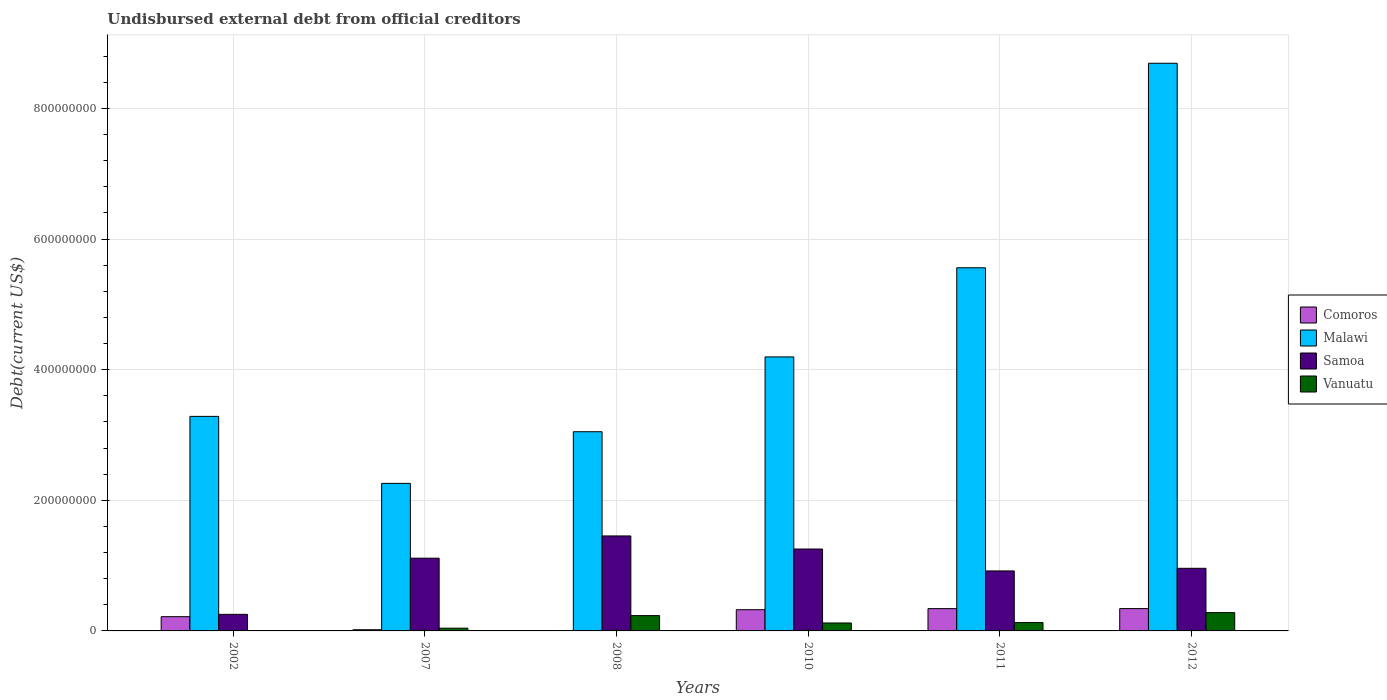How many groups of bars are there?
Your answer should be very brief. 6. Are the number of bars on each tick of the X-axis equal?
Offer a very short reply. Yes. What is the label of the 3rd group of bars from the left?
Your response must be concise. 2008. In how many cases, is the number of bars for a given year not equal to the number of legend labels?
Keep it short and to the point. 0. What is the total debt in Comoros in 2007?
Keep it short and to the point. 1.80e+06. Across all years, what is the maximum total debt in Malawi?
Keep it short and to the point. 8.69e+08. Across all years, what is the minimum total debt in Malawi?
Provide a short and direct response. 2.26e+08. In which year was the total debt in Vanuatu minimum?
Your answer should be very brief. 2002. What is the total total debt in Vanuatu in the graph?
Offer a terse response. 8.06e+07. What is the difference between the total debt in Samoa in 2008 and that in 2011?
Your answer should be very brief. 5.36e+07. What is the difference between the total debt in Malawi in 2011 and the total debt in Comoros in 2002?
Make the answer very short. 5.34e+08. What is the average total debt in Malawi per year?
Provide a succinct answer. 4.51e+08. In the year 2008, what is the difference between the total debt in Malawi and total debt in Comoros?
Give a very brief answer. 3.04e+08. What is the ratio of the total debt in Malawi in 2007 to that in 2012?
Give a very brief answer. 0.26. Is the difference between the total debt in Malawi in 2002 and 2012 greater than the difference between the total debt in Comoros in 2002 and 2012?
Make the answer very short. No. What is the difference between the highest and the second highest total debt in Vanuatu?
Your answer should be very brief. 4.56e+06. What is the difference between the highest and the lowest total debt in Comoros?
Offer a terse response. 3.37e+07. What does the 2nd bar from the left in 2007 represents?
Offer a terse response. Malawi. What does the 4th bar from the right in 2007 represents?
Keep it short and to the point. Comoros. Is it the case that in every year, the sum of the total debt in Comoros and total debt in Malawi is greater than the total debt in Samoa?
Provide a short and direct response. Yes. How many bars are there?
Give a very brief answer. 24. How many years are there in the graph?
Keep it short and to the point. 6. What is the difference between two consecutive major ticks on the Y-axis?
Provide a succinct answer. 2.00e+08. Are the values on the major ticks of Y-axis written in scientific E-notation?
Give a very brief answer. No. Does the graph contain any zero values?
Make the answer very short. No. Does the graph contain grids?
Offer a very short reply. Yes. How are the legend labels stacked?
Give a very brief answer. Vertical. What is the title of the graph?
Provide a succinct answer. Undisbursed external debt from official creditors. What is the label or title of the X-axis?
Your answer should be compact. Years. What is the label or title of the Y-axis?
Keep it short and to the point. Debt(current US$). What is the Debt(current US$) in Comoros in 2002?
Your answer should be very brief. 2.18e+07. What is the Debt(current US$) in Malawi in 2002?
Ensure brevity in your answer.  3.28e+08. What is the Debt(current US$) of Samoa in 2002?
Ensure brevity in your answer.  2.54e+07. What is the Debt(current US$) of Vanuatu in 2002?
Ensure brevity in your answer.  1.20e+04. What is the Debt(current US$) of Comoros in 2007?
Your response must be concise. 1.80e+06. What is the Debt(current US$) of Malawi in 2007?
Offer a terse response. 2.26e+08. What is the Debt(current US$) of Samoa in 2007?
Keep it short and to the point. 1.11e+08. What is the Debt(current US$) of Vanuatu in 2007?
Offer a terse response. 4.20e+06. What is the Debt(current US$) of Comoros in 2008?
Your answer should be compact. 4.97e+05. What is the Debt(current US$) of Malawi in 2008?
Your answer should be compact. 3.05e+08. What is the Debt(current US$) in Samoa in 2008?
Provide a short and direct response. 1.45e+08. What is the Debt(current US$) in Vanuatu in 2008?
Your response must be concise. 2.34e+07. What is the Debt(current US$) of Comoros in 2010?
Offer a terse response. 3.25e+07. What is the Debt(current US$) in Malawi in 2010?
Provide a short and direct response. 4.20e+08. What is the Debt(current US$) in Samoa in 2010?
Your answer should be very brief. 1.25e+08. What is the Debt(current US$) in Vanuatu in 2010?
Offer a very short reply. 1.22e+07. What is the Debt(current US$) in Comoros in 2011?
Your response must be concise. 3.41e+07. What is the Debt(current US$) in Malawi in 2011?
Your answer should be very brief. 5.56e+08. What is the Debt(current US$) in Samoa in 2011?
Your answer should be compact. 9.19e+07. What is the Debt(current US$) of Vanuatu in 2011?
Offer a very short reply. 1.28e+07. What is the Debt(current US$) of Comoros in 2012?
Your answer should be compact. 3.42e+07. What is the Debt(current US$) of Malawi in 2012?
Your answer should be compact. 8.69e+08. What is the Debt(current US$) of Samoa in 2012?
Your answer should be compact. 9.59e+07. What is the Debt(current US$) in Vanuatu in 2012?
Your answer should be compact. 2.80e+07. Across all years, what is the maximum Debt(current US$) of Comoros?
Offer a very short reply. 3.42e+07. Across all years, what is the maximum Debt(current US$) in Malawi?
Provide a succinct answer. 8.69e+08. Across all years, what is the maximum Debt(current US$) of Samoa?
Offer a terse response. 1.45e+08. Across all years, what is the maximum Debt(current US$) in Vanuatu?
Provide a succinct answer. 2.80e+07. Across all years, what is the minimum Debt(current US$) in Comoros?
Offer a very short reply. 4.97e+05. Across all years, what is the minimum Debt(current US$) of Malawi?
Your response must be concise. 2.26e+08. Across all years, what is the minimum Debt(current US$) in Samoa?
Keep it short and to the point. 2.54e+07. Across all years, what is the minimum Debt(current US$) in Vanuatu?
Offer a very short reply. 1.20e+04. What is the total Debt(current US$) in Comoros in the graph?
Your answer should be very brief. 1.25e+08. What is the total Debt(current US$) in Malawi in the graph?
Keep it short and to the point. 2.70e+09. What is the total Debt(current US$) in Samoa in the graph?
Ensure brevity in your answer.  5.95e+08. What is the total Debt(current US$) of Vanuatu in the graph?
Give a very brief answer. 8.06e+07. What is the difference between the Debt(current US$) in Comoros in 2002 and that in 2007?
Give a very brief answer. 2.00e+07. What is the difference between the Debt(current US$) in Malawi in 2002 and that in 2007?
Ensure brevity in your answer.  1.03e+08. What is the difference between the Debt(current US$) of Samoa in 2002 and that in 2007?
Your response must be concise. -8.60e+07. What is the difference between the Debt(current US$) of Vanuatu in 2002 and that in 2007?
Keep it short and to the point. -4.19e+06. What is the difference between the Debt(current US$) of Comoros in 2002 and that in 2008?
Make the answer very short. 2.13e+07. What is the difference between the Debt(current US$) in Malawi in 2002 and that in 2008?
Offer a very short reply. 2.35e+07. What is the difference between the Debt(current US$) in Samoa in 2002 and that in 2008?
Make the answer very short. -1.20e+08. What is the difference between the Debt(current US$) of Vanuatu in 2002 and that in 2008?
Your answer should be compact. -2.34e+07. What is the difference between the Debt(current US$) of Comoros in 2002 and that in 2010?
Ensure brevity in your answer.  -1.07e+07. What is the difference between the Debt(current US$) in Malawi in 2002 and that in 2010?
Keep it short and to the point. -9.10e+07. What is the difference between the Debt(current US$) of Samoa in 2002 and that in 2010?
Your response must be concise. -1.00e+08. What is the difference between the Debt(current US$) in Vanuatu in 2002 and that in 2010?
Offer a terse response. -1.22e+07. What is the difference between the Debt(current US$) of Comoros in 2002 and that in 2011?
Offer a very short reply. -1.23e+07. What is the difference between the Debt(current US$) of Malawi in 2002 and that in 2011?
Make the answer very short. -2.28e+08. What is the difference between the Debt(current US$) in Samoa in 2002 and that in 2011?
Offer a very short reply. -6.65e+07. What is the difference between the Debt(current US$) of Vanuatu in 2002 and that in 2011?
Provide a short and direct response. -1.28e+07. What is the difference between the Debt(current US$) of Comoros in 2002 and that in 2012?
Give a very brief answer. -1.24e+07. What is the difference between the Debt(current US$) in Malawi in 2002 and that in 2012?
Keep it short and to the point. -5.41e+08. What is the difference between the Debt(current US$) of Samoa in 2002 and that in 2012?
Your answer should be very brief. -7.05e+07. What is the difference between the Debt(current US$) in Vanuatu in 2002 and that in 2012?
Give a very brief answer. -2.80e+07. What is the difference between the Debt(current US$) in Comoros in 2007 and that in 2008?
Provide a short and direct response. 1.31e+06. What is the difference between the Debt(current US$) of Malawi in 2007 and that in 2008?
Your answer should be compact. -7.91e+07. What is the difference between the Debt(current US$) of Samoa in 2007 and that in 2008?
Offer a very short reply. -3.40e+07. What is the difference between the Debt(current US$) of Vanuatu in 2007 and that in 2008?
Keep it short and to the point. -1.92e+07. What is the difference between the Debt(current US$) of Comoros in 2007 and that in 2010?
Provide a short and direct response. -3.07e+07. What is the difference between the Debt(current US$) of Malawi in 2007 and that in 2010?
Keep it short and to the point. -1.94e+08. What is the difference between the Debt(current US$) of Samoa in 2007 and that in 2010?
Your answer should be compact. -1.40e+07. What is the difference between the Debt(current US$) of Vanuatu in 2007 and that in 2010?
Your answer should be very brief. -7.97e+06. What is the difference between the Debt(current US$) of Comoros in 2007 and that in 2011?
Give a very brief answer. -3.23e+07. What is the difference between the Debt(current US$) in Malawi in 2007 and that in 2011?
Make the answer very short. -3.30e+08. What is the difference between the Debt(current US$) of Samoa in 2007 and that in 2011?
Make the answer very short. 1.95e+07. What is the difference between the Debt(current US$) in Vanuatu in 2007 and that in 2011?
Your answer should be very brief. -8.59e+06. What is the difference between the Debt(current US$) in Comoros in 2007 and that in 2012?
Ensure brevity in your answer.  -3.24e+07. What is the difference between the Debt(current US$) of Malawi in 2007 and that in 2012?
Your answer should be very brief. -6.43e+08. What is the difference between the Debt(current US$) of Samoa in 2007 and that in 2012?
Provide a succinct answer. 1.55e+07. What is the difference between the Debt(current US$) in Vanuatu in 2007 and that in 2012?
Your answer should be compact. -2.38e+07. What is the difference between the Debt(current US$) of Comoros in 2008 and that in 2010?
Provide a short and direct response. -3.20e+07. What is the difference between the Debt(current US$) of Malawi in 2008 and that in 2010?
Ensure brevity in your answer.  -1.15e+08. What is the difference between the Debt(current US$) in Samoa in 2008 and that in 2010?
Provide a succinct answer. 2.00e+07. What is the difference between the Debt(current US$) in Vanuatu in 2008 and that in 2010?
Offer a terse response. 1.13e+07. What is the difference between the Debt(current US$) of Comoros in 2008 and that in 2011?
Provide a succinct answer. -3.36e+07. What is the difference between the Debt(current US$) in Malawi in 2008 and that in 2011?
Provide a short and direct response. -2.51e+08. What is the difference between the Debt(current US$) of Samoa in 2008 and that in 2011?
Make the answer very short. 5.36e+07. What is the difference between the Debt(current US$) of Vanuatu in 2008 and that in 2011?
Your response must be concise. 1.07e+07. What is the difference between the Debt(current US$) of Comoros in 2008 and that in 2012?
Give a very brief answer. -3.37e+07. What is the difference between the Debt(current US$) of Malawi in 2008 and that in 2012?
Provide a short and direct response. -5.64e+08. What is the difference between the Debt(current US$) of Samoa in 2008 and that in 2012?
Ensure brevity in your answer.  4.95e+07. What is the difference between the Debt(current US$) in Vanuatu in 2008 and that in 2012?
Keep it short and to the point. -4.56e+06. What is the difference between the Debt(current US$) in Comoros in 2010 and that in 2011?
Make the answer very short. -1.66e+06. What is the difference between the Debt(current US$) in Malawi in 2010 and that in 2011?
Make the answer very short. -1.36e+08. What is the difference between the Debt(current US$) in Samoa in 2010 and that in 2011?
Ensure brevity in your answer.  3.35e+07. What is the difference between the Debt(current US$) of Vanuatu in 2010 and that in 2011?
Make the answer very short. -6.22e+05. What is the difference between the Debt(current US$) in Comoros in 2010 and that in 2012?
Your response must be concise. -1.72e+06. What is the difference between the Debt(current US$) in Malawi in 2010 and that in 2012?
Make the answer very short. -4.50e+08. What is the difference between the Debt(current US$) in Samoa in 2010 and that in 2012?
Your response must be concise. 2.95e+07. What is the difference between the Debt(current US$) of Vanuatu in 2010 and that in 2012?
Offer a terse response. -1.58e+07. What is the difference between the Debt(current US$) of Comoros in 2011 and that in 2012?
Make the answer very short. -6.10e+04. What is the difference between the Debt(current US$) in Malawi in 2011 and that in 2012?
Your answer should be compact. -3.13e+08. What is the difference between the Debt(current US$) of Samoa in 2011 and that in 2012?
Offer a very short reply. -4.03e+06. What is the difference between the Debt(current US$) in Vanuatu in 2011 and that in 2012?
Ensure brevity in your answer.  -1.52e+07. What is the difference between the Debt(current US$) of Comoros in 2002 and the Debt(current US$) of Malawi in 2007?
Make the answer very short. -2.04e+08. What is the difference between the Debt(current US$) of Comoros in 2002 and the Debt(current US$) of Samoa in 2007?
Your response must be concise. -8.96e+07. What is the difference between the Debt(current US$) of Comoros in 2002 and the Debt(current US$) of Vanuatu in 2007?
Offer a very short reply. 1.76e+07. What is the difference between the Debt(current US$) of Malawi in 2002 and the Debt(current US$) of Samoa in 2007?
Ensure brevity in your answer.  2.17e+08. What is the difference between the Debt(current US$) in Malawi in 2002 and the Debt(current US$) in Vanuatu in 2007?
Give a very brief answer. 3.24e+08. What is the difference between the Debt(current US$) of Samoa in 2002 and the Debt(current US$) of Vanuatu in 2007?
Offer a very short reply. 2.12e+07. What is the difference between the Debt(current US$) of Comoros in 2002 and the Debt(current US$) of Malawi in 2008?
Give a very brief answer. -2.83e+08. What is the difference between the Debt(current US$) of Comoros in 2002 and the Debt(current US$) of Samoa in 2008?
Offer a very short reply. -1.24e+08. What is the difference between the Debt(current US$) in Comoros in 2002 and the Debt(current US$) in Vanuatu in 2008?
Your response must be concise. -1.63e+06. What is the difference between the Debt(current US$) of Malawi in 2002 and the Debt(current US$) of Samoa in 2008?
Offer a very short reply. 1.83e+08. What is the difference between the Debt(current US$) in Malawi in 2002 and the Debt(current US$) in Vanuatu in 2008?
Your answer should be very brief. 3.05e+08. What is the difference between the Debt(current US$) in Samoa in 2002 and the Debt(current US$) in Vanuatu in 2008?
Provide a succinct answer. 1.92e+06. What is the difference between the Debt(current US$) of Comoros in 2002 and the Debt(current US$) of Malawi in 2010?
Make the answer very short. -3.98e+08. What is the difference between the Debt(current US$) of Comoros in 2002 and the Debt(current US$) of Samoa in 2010?
Your answer should be very brief. -1.04e+08. What is the difference between the Debt(current US$) of Comoros in 2002 and the Debt(current US$) of Vanuatu in 2010?
Keep it short and to the point. 9.65e+06. What is the difference between the Debt(current US$) of Malawi in 2002 and the Debt(current US$) of Samoa in 2010?
Make the answer very short. 2.03e+08. What is the difference between the Debt(current US$) of Malawi in 2002 and the Debt(current US$) of Vanuatu in 2010?
Provide a short and direct response. 3.16e+08. What is the difference between the Debt(current US$) in Samoa in 2002 and the Debt(current US$) in Vanuatu in 2010?
Give a very brief answer. 1.32e+07. What is the difference between the Debt(current US$) in Comoros in 2002 and the Debt(current US$) in Malawi in 2011?
Offer a terse response. -5.34e+08. What is the difference between the Debt(current US$) in Comoros in 2002 and the Debt(current US$) in Samoa in 2011?
Keep it short and to the point. -7.00e+07. What is the difference between the Debt(current US$) of Comoros in 2002 and the Debt(current US$) of Vanuatu in 2011?
Offer a terse response. 9.03e+06. What is the difference between the Debt(current US$) of Malawi in 2002 and the Debt(current US$) of Samoa in 2011?
Your answer should be compact. 2.37e+08. What is the difference between the Debt(current US$) of Malawi in 2002 and the Debt(current US$) of Vanuatu in 2011?
Give a very brief answer. 3.16e+08. What is the difference between the Debt(current US$) in Samoa in 2002 and the Debt(current US$) in Vanuatu in 2011?
Provide a succinct answer. 1.26e+07. What is the difference between the Debt(current US$) in Comoros in 2002 and the Debt(current US$) in Malawi in 2012?
Keep it short and to the point. -8.47e+08. What is the difference between the Debt(current US$) in Comoros in 2002 and the Debt(current US$) in Samoa in 2012?
Offer a terse response. -7.41e+07. What is the difference between the Debt(current US$) in Comoros in 2002 and the Debt(current US$) in Vanuatu in 2012?
Offer a very short reply. -6.18e+06. What is the difference between the Debt(current US$) in Malawi in 2002 and the Debt(current US$) in Samoa in 2012?
Make the answer very short. 2.33e+08. What is the difference between the Debt(current US$) of Malawi in 2002 and the Debt(current US$) of Vanuatu in 2012?
Keep it short and to the point. 3.00e+08. What is the difference between the Debt(current US$) of Samoa in 2002 and the Debt(current US$) of Vanuatu in 2012?
Ensure brevity in your answer.  -2.64e+06. What is the difference between the Debt(current US$) of Comoros in 2007 and the Debt(current US$) of Malawi in 2008?
Your answer should be very brief. -3.03e+08. What is the difference between the Debt(current US$) in Comoros in 2007 and the Debt(current US$) in Samoa in 2008?
Provide a succinct answer. -1.44e+08. What is the difference between the Debt(current US$) of Comoros in 2007 and the Debt(current US$) of Vanuatu in 2008?
Make the answer very short. -2.16e+07. What is the difference between the Debt(current US$) of Malawi in 2007 and the Debt(current US$) of Samoa in 2008?
Ensure brevity in your answer.  8.05e+07. What is the difference between the Debt(current US$) in Malawi in 2007 and the Debt(current US$) in Vanuatu in 2008?
Make the answer very short. 2.02e+08. What is the difference between the Debt(current US$) in Samoa in 2007 and the Debt(current US$) in Vanuatu in 2008?
Your answer should be very brief. 8.79e+07. What is the difference between the Debt(current US$) in Comoros in 2007 and the Debt(current US$) in Malawi in 2010?
Your answer should be compact. -4.18e+08. What is the difference between the Debt(current US$) in Comoros in 2007 and the Debt(current US$) in Samoa in 2010?
Your answer should be very brief. -1.24e+08. What is the difference between the Debt(current US$) in Comoros in 2007 and the Debt(current US$) in Vanuatu in 2010?
Provide a short and direct response. -1.04e+07. What is the difference between the Debt(current US$) of Malawi in 2007 and the Debt(current US$) of Samoa in 2010?
Provide a short and direct response. 1.01e+08. What is the difference between the Debt(current US$) of Malawi in 2007 and the Debt(current US$) of Vanuatu in 2010?
Offer a very short reply. 2.14e+08. What is the difference between the Debt(current US$) in Samoa in 2007 and the Debt(current US$) in Vanuatu in 2010?
Offer a very short reply. 9.92e+07. What is the difference between the Debt(current US$) in Comoros in 2007 and the Debt(current US$) in Malawi in 2011?
Your answer should be compact. -5.54e+08. What is the difference between the Debt(current US$) of Comoros in 2007 and the Debt(current US$) of Samoa in 2011?
Your answer should be very brief. -9.00e+07. What is the difference between the Debt(current US$) in Comoros in 2007 and the Debt(current US$) in Vanuatu in 2011?
Your answer should be very brief. -1.10e+07. What is the difference between the Debt(current US$) of Malawi in 2007 and the Debt(current US$) of Samoa in 2011?
Your answer should be compact. 1.34e+08. What is the difference between the Debt(current US$) of Malawi in 2007 and the Debt(current US$) of Vanuatu in 2011?
Keep it short and to the point. 2.13e+08. What is the difference between the Debt(current US$) in Samoa in 2007 and the Debt(current US$) in Vanuatu in 2011?
Offer a terse response. 9.86e+07. What is the difference between the Debt(current US$) in Comoros in 2007 and the Debt(current US$) in Malawi in 2012?
Offer a terse response. -8.67e+08. What is the difference between the Debt(current US$) of Comoros in 2007 and the Debt(current US$) of Samoa in 2012?
Your response must be concise. -9.41e+07. What is the difference between the Debt(current US$) in Comoros in 2007 and the Debt(current US$) in Vanuatu in 2012?
Make the answer very short. -2.62e+07. What is the difference between the Debt(current US$) of Malawi in 2007 and the Debt(current US$) of Samoa in 2012?
Your answer should be compact. 1.30e+08. What is the difference between the Debt(current US$) of Malawi in 2007 and the Debt(current US$) of Vanuatu in 2012?
Ensure brevity in your answer.  1.98e+08. What is the difference between the Debt(current US$) in Samoa in 2007 and the Debt(current US$) in Vanuatu in 2012?
Give a very brief answer. 8.34e+07. What is the difference between the Debt(current US$) of Comoros in 2008 and the Debt(current US$) of Malawi in 2010?
Your answer should be compact. -4.19e+08. What is the difference between the Debt(current US$) of Comoros in 2008 and the Debt(current US$) of Samoa in 2010?
Ensure brevity in your answer.  -1.25e+08. What is the difference between the Debt(current US$) of Comoros in 2008 and the Debt(current US$) of Vanuatu in 2010?
Make the answer very short. -1.17e+07. What is the difference between the Debt(current US$) in Malawi in 2008 and the Debt(current US$) in Samoa in 2010?
Keep it short and to the point. 1.80e+08. What is the difference between the Debt(current US$) of Malawi in 2008 and the Debt(current US$) of Vanuatu in 2010?
Your answer should be compact. 2.93e+08. What is the difference between the Debt(current US$) in Samoa in 2008 and the Debt(current US$) in Vanuatu in 2010?
Give a very brief answer. 1.33e+08. What is the difference between the Debt(current US$) in Comoros in 2008 and the Debt(current US$) in Malawi in 2011?
Offer a very short reply. -5.55e+08. What is the difference between the Debt(current US$) of Comoros in 2008 and the Debt(current US$) of Samoa in 2011?
Offer a very short reply. -9.14e+07. What is the difference between the Debt(current US$) in Comoros in 2008 and the Debt(current US$) in Vanuatu in 2011?
Keep it short and to the point. -1.23e+07. What is the difference between the Debt(current US$) in Malawi in 2008 and the Debt(current US$) in Samoa in 2011?
Provide a succinct answer. 2.13e+08. What is the difference between the Debt(current US$) of Malawi in 2008 and the Debt(current US$) of Vanuatu in 2011?
Make the answer very short. 2.92e+08. What is the difference between the Debt(current US$) in Samoa in 2008 and the Debt(current US$) in Vanuatu in 2011?
Your answer should be compact. 1.33e+08. What is the difference between the Debt(current US$) in Comoros in 2008 and the Debt(current US$) in Malawi in 2012?
Give a very brief answer. -8.69e+08. What is the difference between the Debt(current US$) of Comoros in 2008 and the Debt(current US$) of Samoa in 2012?
Provide a succinct answer. -9.54e+07. What is the difference between the Debt(current US$) in Comoros in 2008 and the Debt(current US$) in Vanuatu in 2012?
Provide a succinct answer. -2.75e+07. What is the difference between the Debt(current US$) in Malawi in 2008 and the Debt(current US$) in Samoa in 2012?
Your response must be concise. 2.09e+08. What is the difference between the Debt(current US$) in Malawi in 2008 and the Debt(current US$) in Vanuatu in 2012?
Offer a very short reply. 2.77e+08. What is the difference between the Debt(current US$) in Samoa in 2008 and the Debt(current US$) in Vanuatu in 2012?
Provide a succinct answer. 1.17e+08. What is the difference between the Debt(current US$) of Comoros in 2010 and the Debt(current US$) of Malawi in 2011?
Make the answer very short. -5.24e+08. What is the difference between the Debt(current US$) in Comoros in 2010 and the Debt(current US$) in Samoa in 2011?
Offer a very short reply. -5.94e+07. What is the difference between the Debt(current US$) in Comoros in 2010 and the Debt(current US$) in Vanuatu in 2011?
Make the answer very short. 1.97e+07. What is the difference between the Debt(current US$) in Malawi in 2010 and the Debt(current US$) in Samoa in 2011?
Offer a terse response. 3.28e+08. What is the difference between the Debt(current US$) in Malawi in 2010 and the Debt(current US$) in Vanuatu in 2011?
Your answer should be very brief. 4.07e+08. What is the difference between the Debt(current US$) in Samoa in 2010 and the Debt(current US$) in Vanuatu in 2011?
Give a very brief answer. 1.13e+08. What is the difference between the Debt(current US$) in Comoros in 2010 and the Debt(current US$) in Malawi in 2012?
Give a very brief answer. -8.37e+08. What is the difference between the Debt(current US$) of Comoros in 2010 and the Debt(current US$) of Samoa in 2012?
Ensure brevity in your answer.  -6.34e+07. What is the difference between the Debt(current US$) in Comoros in 2010 and the Debt(current US$) in Vanuatu in 2012?
Your answer should be compact. 4.47e+06. What is the difference between the Debt(current US$) in Malawi in 2010 and the Debt(current US$) in Samoa in 2012?
Offer a terse response. 3.24e+08. What is the difference between the Debt(current US$) of Malawi in 2010 and the Debt(current US$) of Vanuatu in 2012?
Ensure brevity in your answer.  3.92e+08. What is the difference between the Debt(current US$) of Samoa in 2010 and the Debt(current US$) of Vanuatu in 2012?
Give a very brief answer. 9.74e+07. What is the difference between the Debt(current US$) in Comoros in 2011 and the Debt(current US$) in Malawi in 2012?
Your answer should be compact. -8.35e+08. What is the difference between the Debt(current US$) in Comoros in 2011 and the Debt(current US$) in Samoa in 2012?
Offer a terse response. -6.18e+07. What is the difference between the Debt(current US$) in Comoros in 2011 and the Debt(current US$) in Vanuatu in 2012?
Keep it short and to the point. 6.12e+06. What is the difference between the Debt(current US$) of Malawi in 2011 and the Debt(current US$) of Samoa in 2012?
Offer a terse response. 4.60e+08. What is the difference between the Debt(current US$) of Malawi in 2011 and the Debt(current US$) of Vanuatu in 2012?
Ensure brevity in your answer.  5.28e+08. What is the difference between the Debt(current US$) in Samoa in 2011 and the Debt(current US$) in Vanuatu in 2012?
Keep it short and to the point. 6.39e+07. What is the average Debt(current US$) in Comoros per year?
Your answer should be very brief. 2.08e+07. What is the average Debt(current US$) in Malawi per year?
Ensure brevity in your answer.  4.51e+08. What is the average Debt(current US$) in Samoa per year?
Keep it short and to the point. 9.92e+07. What is the average Debt(current US$) in Vanuatu per year?
Offer a very short reply. 1.34e+07. In the year 2002, what is the difference between the Debt(current US$) of Comoros and Debt(current US$) of Malawi?
Ensure brevity in your answer.  -3.07e+08. In the year 2002, what is the difference between the Debt(current US$) of Comoros and Debt(current US$) of Samoa?
Offer a terse response. -3.55e+06. In the year 2002, what is the difference between the Debt(current US$) of Comoros and Debt(current US$) of Vanuatu?
Offer a very short reply. 2.18e+07. In the year 2002, what is the difference between the Debt(current US$) of Malawi and Debt(current US$) of Samoa?
Provide a short and direct response. 3.03e+08. In the year 2002, what is the difference between the Debt(current US$) of Malawi and Debt(current US$) of Vanuatu?
Provide a short and direct response. 3.28e+08. In the year 2002, what is the difference between the Debt(current US$) in Samoa and Debt(current US$) in Vanuatu?
Your response must be concise. 2.53e+07. In the year 2007, what is the difference between the Debt(current US$) in Comoros and Debt(current US$) in Malawi?
Give a very brief answer. -2.24e+08. In the year 2007, what is the difference between the Debt(current US$) in Comoros and Debt(current US$) in Samoa?
Offer a terse response. -1.10e+08. In the year 2007, what is the difference between the Debt(current US$) of Comoros and Debt(current US$) of Vanuatu?
Keep it short and to the point. -2.39e+06. In the year 2007, what is the difference between the Debt(current US$) of Malawi and Debt(current US$) of Samoa?
Your answer should be compact. 1.15e+08. In the year 2007, what is the difference between the Debt(current US$) of Malawi and Debt(current US$) of Vanuatu?
Ensure brevity in your answer.  2.22e+08. In the year 2007, what is the difference between the Debt(current US$) in Samoa and Debt(current US$) in Vanuatu?
Give a very brief answer. 1.07e+08. In the year 2008, what is the difference between the Debt(current US$) of Comoros and Debt(current US$) of Malawi?
Offer a very short reply. -3.04e+08. In the year 2008, what is the difference between the Debt(current US$) of Comoros and Debt(current US$) of Samoa?
Your answer should be compact. -1.45e+08. In the year 2008, what is the difference between the Debt(current US$) of Comoros and Debt(current US$) of Vanuatu?
Give a very brief answer. -2.29e+07. In the year 2008, what is the difference between the Debt(current US$) in Malawi and Debt(current US$) in Samoa?
Your response must be concise. 1.60e+08. In the year 2008, what is the difference between the Debt(current US$) of Malawi and Debt(current US$) of Vanuatu?
Your answer should be very brief. 2.82e+08. In the year 2008, what is the difference between the Debt(current US$) in Samoa and Debt(current US$) in Vanuatu?
Keep it short and to the point. 1.22e+08. In the year 2010, what is the difference between the Debt(current US$) of Comoros and Debt(current US$) of Malawi?
Offer a very short reply. -3.87e+08. In the year 2010, what is the difference between the Debt(current US$) of Comoros and Debt(current US$) of Samoa?
Your answer should be compact. -9.29e+07. In the year 2010, what is the difference between the Debt(current US$) of Comoros and Debt(current US$) of Vanuatu?
Give a very brief answer. 2.03e+07. In the year 2010, what is the difference between the Debt(current US$) of Malawi and Debt(current US$) of Samoa?
Keep it short and to the point. 2.94e+08. In the year 2010, what is the difference between the Debt(current US$) in Malawi and Debt(current US$) in Vanuatu?
Offer a very short reply. 4.07e+08. In the year 2010, what is the difference between the Debt(current US$) in Samoa and Debt(current US$) in Vanuatu?
Your response must be concise. 1.13e+08. In the year 2011, what is the difference between the Debt(current US$) in Comoros and Debt(current US$) in Malawi?
Provide a short and direct response. -5.22e+08. In the year 2011, what is the difference between the Debt(current US$) in Comoros and Debt(current US$) in Samoa?
Make the answer very short. -5.77e+07. In the year 2011, what is the difference between the Debt(current US$) of Comoros and Debt(current US$) of Vanuatu?
Your response must be concise. 2.13e+07. In the year 2011, what is the difference between the Debt(current US$) of Malawi and Debt(current US$) of Samoa?
Offer a terse response. 4.64e+08. In the year 2011, what is the difference between the Debt(current US$) of Malawi and Debt(current US$) of Vanuatu?
Offer a very short reply. 5.43e+08. In the year 2011, what is the difference between the Debt(current US$) of Samoa and Debt(current US$) of Vanuatu?
Provide a short and direct response. 7.91e+07. In the year 2012, what is the difference between the Debt(current US$) in Comoros and Debt(current US$) in Malawi?
Ensure brevity in your answer.  -8.35e+08. In the year 2012, what is the difference between the Debt(current US$) of Comoros and Debt(current US$) of Samoa?
Make the answer very short. -6.17e+07. In the year 2012, what is the difference between the Debt(current US$) in Comoros and Debt(current US$) in Vanuatu?
Your answer should be compact. 6.19e+06. In the year 2012, what is the difference between the Debt(current US$) in Malawi and Debt(current US$) in Samoa?
Make the answer very short. 7.73e+08. In the year 2012, what is the difference between the Debt(current US$) of Malawi and Debt(current US$) of Vanuatu?
Keep it short and to the point. 8.41e+08. In the year 2012, what is the difference between the Debt(current US$) in Samoa and Debt(current US$) in Vanuatu?
Your answer should be very brief. 6.79e+07. What is the ratio of the Debt(current US$) in Comoros in 2002 to that in 2007?
Your response must be concise. 12.08. What is the ratio of the Debt(current US$) of Malawi in 2002 to that in 2007?
Provide a succinct answer. 1.45. What is the ratio of the Debt(current US$) of Samoa in 2002 to that in 2007?
Offer a terse response. 0.23. What is the ratio of the Debt(current US$) in Vanuatu in 2002 to that in 2007?
Offer a terse response. 0. What is the ratio of the Debt(current US$) of Comoros in 2002 to that in 2008?
Provide a succinct answer. 43.89. What is the ratio of the Debt(current US$) of Malawi in 2002 to that in 2008?
Ensure brevity in your answer.  1.08. What is the ratio of the Debt(current US$) of Samoa in 2002 to that in 2008?
Make the answer very short. 0.17. What is the ratio of the Debt(current US$) of Vanuatu in 2002 to that in 2008?
Keep it short and to the point. 0. What is the ratio of the Debt(current US$) of Comoros in 2002 to that in 2010?
Make the answer very short. 0.67. What is the ratio of the Debt(current US$) in Malawi in 2002 to that in 2010?
Provide a short and direct response. 0.78. What is the ratio of the Debt(current US$) of Samoa in 2002 to that in 2010?
Give a very brief answer. 0.2. What is the ratio of the Debt(current US$) of Vanuatu in 2002 to that in 2010?
Provide a short and direct response. 0. What is the ratio of the Debt(current US$) in Comoros in 2002 to that in 2011?
Your response must be concise. 0.64. What is the ratio of the Debt(current US$) of Malawi in 2002 to that in 2011?
Provide a short and direct response. 0.59. What is the ratio of the Debt(current US$) of Samoa in 2002 to that in 2011?
Make the answer very short. 0.28. What is the ratio of the Debt(current US$) in Vanuatu in 2002 to that in 2011?
Your answer should be compact. 0. What is the ratio of the Debt(current US$) in Comoros in 2002 to that in 2012?
Offer a very short reply. 0.64. What is the ratio of the Debt(current US$) of Malawi in 2002 to that in 2012?
Offer a very short reply. 0.38. What is the ratio of the Debt(current US$) in Samoa in 2002 to that in 2012?
Keep it short and to the point. 0.26. What is the ratio of the Debt(current US$) in Vanuatu in 2002 to that in 2012?
Keep it short and to the point. 0. What is the ratio of the Debt(current US$) of Comoros in 2007 to that in 2008?
Provide a short and direct response. 3.63. What is the ratio of the Debt(current US$) in Malawi in 2007 to that in 2008?
Provide a succinct answer. 0.74. What is the ratio of the Debt(current US$) in Samoa in 2007 to that in 2008?
Give a very brief answer. 0.77. What is the ratio of the Debt(current US$) of Vanuatu in 2007 to that in 2008?
Make the answer very short. 0.18. What is the ratio of the Debt(current US$) in Comoros in 2007 to that in 2010?
Make the answer very short. 0.06. What is the ratio of the Debt(current US$) in Malawi in 2007 to that in 2010?
Your answer should be very brief. 0.54. What is the ratio of the Debt(current US$) of Samoa in 2007 to that in 2010?
Offer a terse response. 0.89. What is the ratio of the Debt(current US$) in Vanuatu in 2007 to that in 2010?
Offer a terse response. 0.35. What is the ratio of the Debt(current US$) of Comoros in 2007 to that in 2011?
Give a very brief answer. 0.05. What is the ratio of the Debt(current US$) of Malawi in 2007 to that in 2011?
Your response must be concise. 0.41. What is the ratio of the Debt(current US$) in Samoa in 2007 to that in 2011?
Give a very brief answer. 1.21. What is the ratio of the Debt(current US$) of Vanuatu in 2007 to that in 2011?
Your answer should be compact. 0.33. What is the ratio of the Debt(current US$) in Comoros in 2007 to that in 2012?
Offer a very short reply. 0.05. What is the ratio of the Debt(current US$) in Malawi in 2007 to that in 2012?
Ensure brevity in your answer.  0.26. What is the ratio of the Debt(current US$) of Samoa in 2007 to that in 2012?
Provide a short and direct response. 1.16. What is the ratio of the Debt(current US$) of Vanuatu in 2007 to that in 2012?
Offer a very short reply. 0.15. What is the ratio of the Debt(current US$) in Comoros in 2008 to that in 2010?
Give a very brief answer. 0.02. What is the ratio of the Debt(current US$) of Malawi in 2008 to that in 2010?
Offer a very short reply. 0.73. What is the ratio of the Debt(current US$) in Samoa in 2008 to that in 2010?
Give a very brief answer. 1.16. What is the ratio of the Debt(current US$) of Vanuatu in 2008 to that in 2010?
Provide a short and direct response. 1.93. What is the ratio of the Debt(current US$) in Comoros in 2008 to that in 2011?
Your answer should be very brief. 0.01. What is the ratio of the Debt(current US$) of Malawi in 2008 to that in 2011?
Ensure brevity in your answer.  0.55. What is the ratio of the Debt(current US$) in Samoa in 2008 to that in 2011?
Offer a terse response. 1.58. What is the ratio of the Debt(current US$) of Vanuatu in 2008 to that in 2011?
Offer a terse response. 1.83. What is the ratio of the Debt(current US$) of Comoros in 2008 to that in 2012?
Your response must be concise. 0.01. What is the ratio of the Debt(current US$) in Malawi in 2008 to that in 2012?
Keep it short and to the point. 0.35. What is the ratio of the Debt(current US$) in Samoa in 2008 to that in 2012?
Keep it short and to the point. 1.52. What is the ratio of the Debt(current US$) in Vanuatu in 2008 to that in 2012?
Make the answer very short. 0.84. What is the ratio of the Debt(current US$) in Comoros in 2010 to that in 2011?
Your answer should be very brief. 0.95. What is the ratio of the Debt(current US$) in Malawi in 2010 to that in 2011?
Provide a short and direct response. 0.75. What is the ratio of the Debt(current US$) in Samoa in 2010 to that in 2011?
Give a very brief answer. 1.37. What is the ratio of the Debt(current US$) of Vanuatu in 2010 to that in 2011?
Provide a succinct answer. 0.95. What is the ratio of the Debt(current US$) in Comoros in 2010 to that in 2012?
Offer a very short reply. 0.95. What is the ratio of the Debt(current US$) of Malawi in 2010 to that in 2012?
Give a very brief answer. 0.48. What is the ratio of the Debt(current US$) of Samoa in 2010 to that in 2012?
Ensure brevity in your answer.  1.31. What is the ratio of the Debt(current US$) in Vanuatu in 2010 to that in 2012?
Offer a very short reply. 0.43. What is the ratio of the Debt(current US$) of Comoros in 2011 to that in 2012?
Keep it short and to the point. 1. What is the ratio of the Debt(current US$) in Malawi in 2011 to that in 2012?
Your response must be concise. 0.64. What is the ratio of the Debt(current US$) of Samoa in 2011 to that in 2012?
Offer a terse response. 0.96. What is the ratio of the Debt(current US$) of Vanuatu in 2011 to that in 2012?
Provide a short and direct response. 0.46. What is the difference between the highest and the second highest Debt(current US$) of Comoros?
Make the answer very short. 6.10e+04. What is the difference between the highest and the second highest Debt(current US$) in Malawi?
Ensure brevity in your answer.  3.13e+08. What is the difference between the highest and the second highest Debt(current US$) of Samoa?
Provide a short and direct response. 2.00e+07. What is the difference between the highest and the second highest Debt(current US$) in Vanuatu?
Ensure brevity in your answer.  4.56e+06. What is the difference between the highest and the lowest Debt(current US$) of Comoros?
Ensure brevity in your answer.  3.37e+07. What is the difference between the highest and the lowest Debt(current US$) of Malawi?
Provide a short and direct response. 6.43e+08. What is the difference between the highest and the lowest Debt(current US$) of Samoa?
Make the answer very short. 1.20e+08. What is the difference between the highest and the lowest Debt(current US$) in Vanuatu?
Your response must be concise. 2.80e+07. 